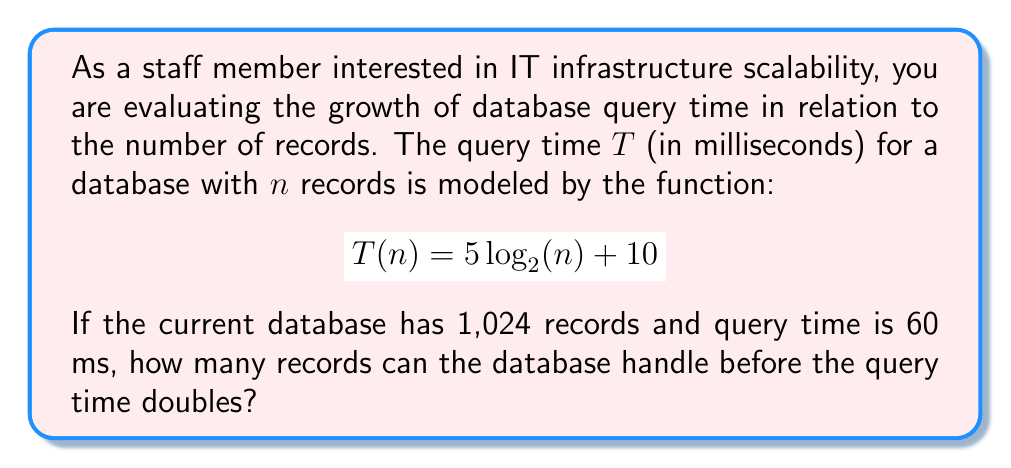Teach me how to tackle this problem. Let's approach this step-by-step:

1) First, we need to verify the current situation:
   For $n = 1024$, $T(1024) = 5 \log_2(1024) + 10$
   
   $$\begin{align}
   T(1024) &= 5 \log_2(2^{10}) + 10 \\
           &= 5(10) + 10 \\
           &= 60 \text{ ms}
   \end{align}$$

   This confirms the given information.

2) Now, we need to find $n$ when the query time doubles to 120 ms:
   
   $$120 = 5 \log_2(n) + 10$$

3) Solve for $\log_2(n)$:
   
   $$\begin{align}
   110 &= 5 \log_2(n) \\
   22 &= \log_2(n)
   \end{align}$$

4) Now we can solve for $n$:
   
   $$n = 2^{22} = 4,194,304$$

5) To find how many more records this is compared to the current situation:
   
   $$4,194,304 - 1,024 = 4,193,280$$

This logarithmic model demonstrates how the database can handle a significant increase in records with only a doubling of query time, showcasing the scalability of the system.
Answer: The database can handle 4,193,280 more records (reaching a total of 4,194,304 records) before the query time doubles to 120 ms. 